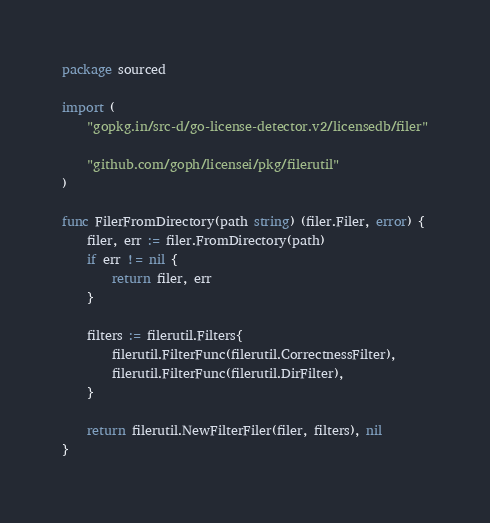Convert code to text. <code><loc_0><loc_0><loc_500><loc_500><_Go_>package sourced

import (
	"gopkg.in/src-d/go-license-detector.v2/licensedb/filer"

	"github.com/goph/licensei/pkg/filerutil"
)

func FilerFromDirectory(path string) (filer.Filer, error) {
	filer, err := filer.FromDirectory(path)
	if err != nil {
		return filer, err
	}

	filters := filerutil.Filters{
		filerutil.FilterFunc(filerutil.CorrectnessFilter),
		filerutil.FilterFunc(filerutil.DirFilter),
	}

	return filerutil.NewFilterFiler(filer, filters), nil
}
</code> 